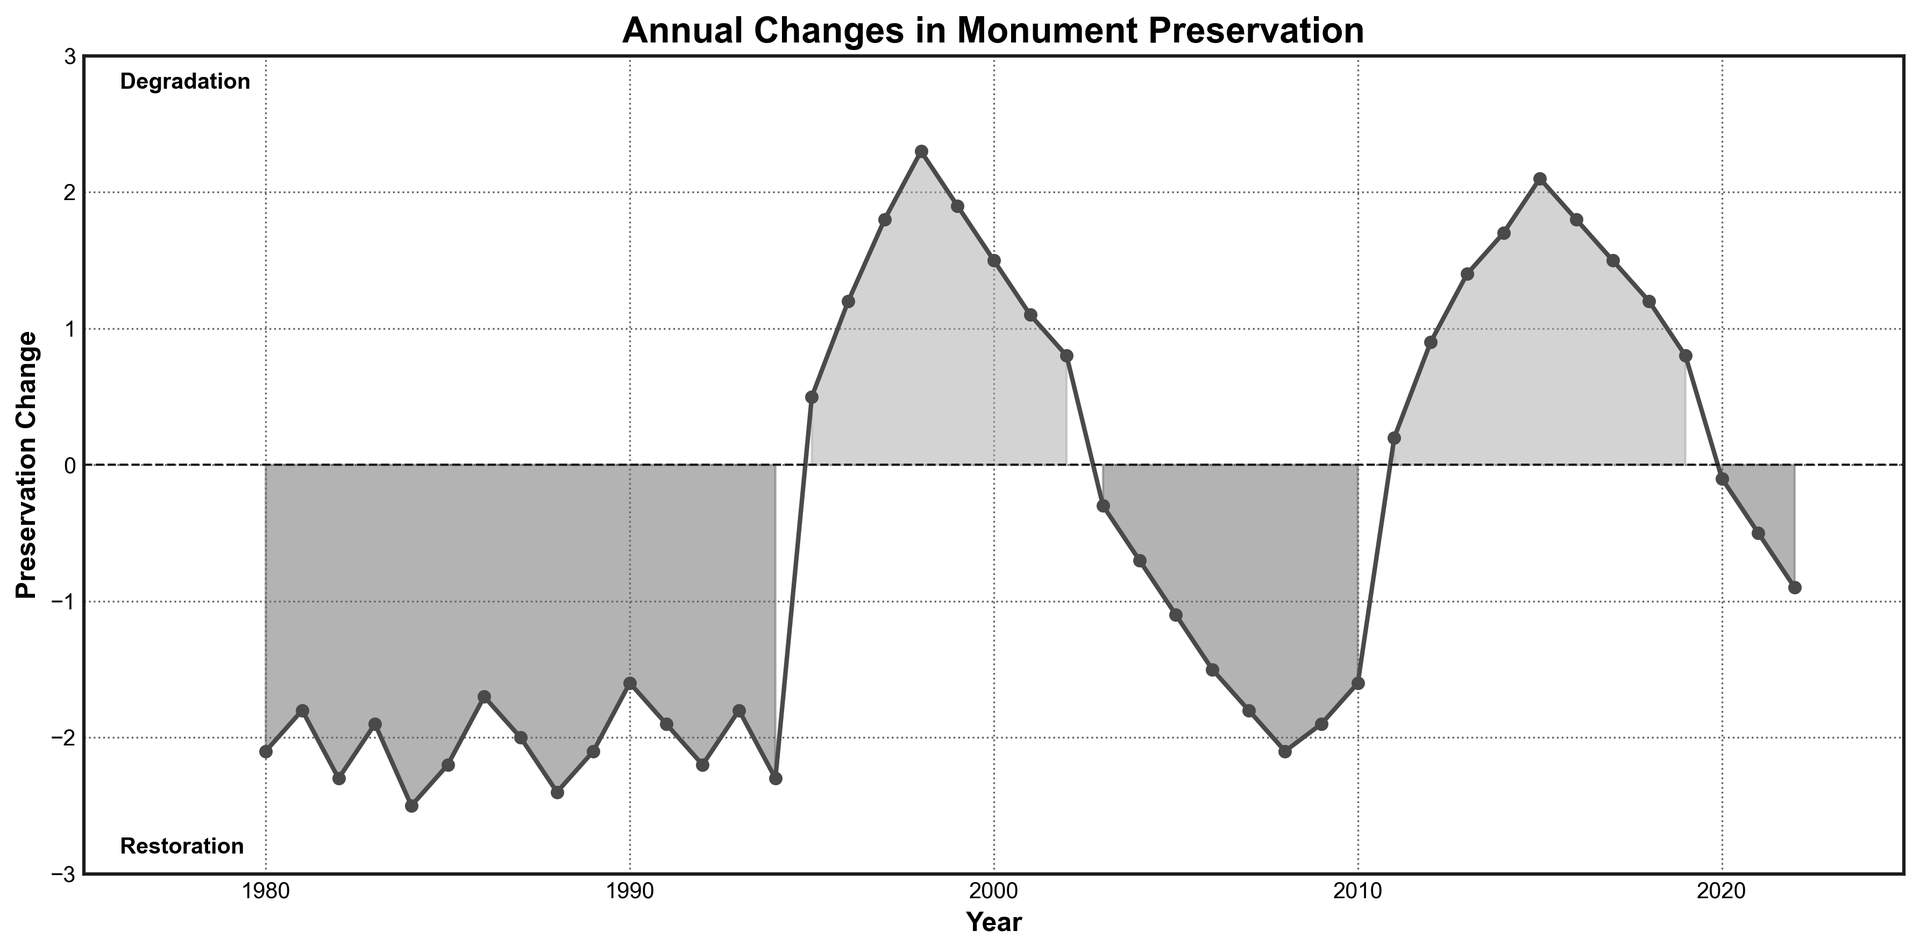What is the overall trend of preservation change from 1995 to 2003? From 1995 to 2003, the chart shows both positive and negative values, indicating a period of restoration followed by degradation. Specifically, it starts with restoration (positive changes) until 2002 and then shifts to degradation (negative change) in 2003.
Answer: Restoration followed by degradation Which year marks the highest restoration effort? To find the highest restoration effort, look for the peak positive value in the plot. The highest point is in 1998 with a value of 2.3.
Answer: 1998 How many years show a positive preservation change? Count the number of points above the zero line. The years 1995-2002, 2011-2019 show positive values.
Answer: 17 years Which period had the longest continuous degradation? Identify the longest section below the zero line. The period 1980 to 1994 spans 15 consecutive years of degradation.
Answer: 15 years What is the median value of preservation change from 1980 to 2022? Sorting the values from 1980 to 2022: the median is the middle value in a list of 43 numbers (index 22), which is around 0.
Answer: 0 During which year did the restoration efforts start after a long period of degradation? Restoration efforts (positive changes) started in the year after the last negative change before a period of successive positive values. From the chart, this is 1995.
Answer: 1995 What was the preservation change in 2000, and how does it compare to the value in 2015? The preservation change in 2000 was 1.5 and in 2015 it was 2.1. The difference is 2.1 - 1.5 = 0.6, indicating an increase.
Answer: 0.6 increase When looking from 1980 to 1990, which year had the least degradation? From the chart, the least negative value between 1980 and 1990 is -1.6 in 1990.
Answer: 1990 